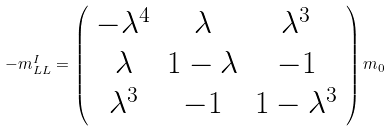<formula> <loc_0><loc_0><loc_500><loc_500>- m _ { L L } ^ { I } = \left ( \begin{array} { c c c } - \lambda ^ { 4 } & \lambda & \lambda ^ { 3 } \\ \lambda & 1 - \lambda & - 1 \\ \lambda ^ { 3 } & - 1 & 1 - \lambda ^ { 3 } \end{array} \right ) m _ { 0 }</formula> 